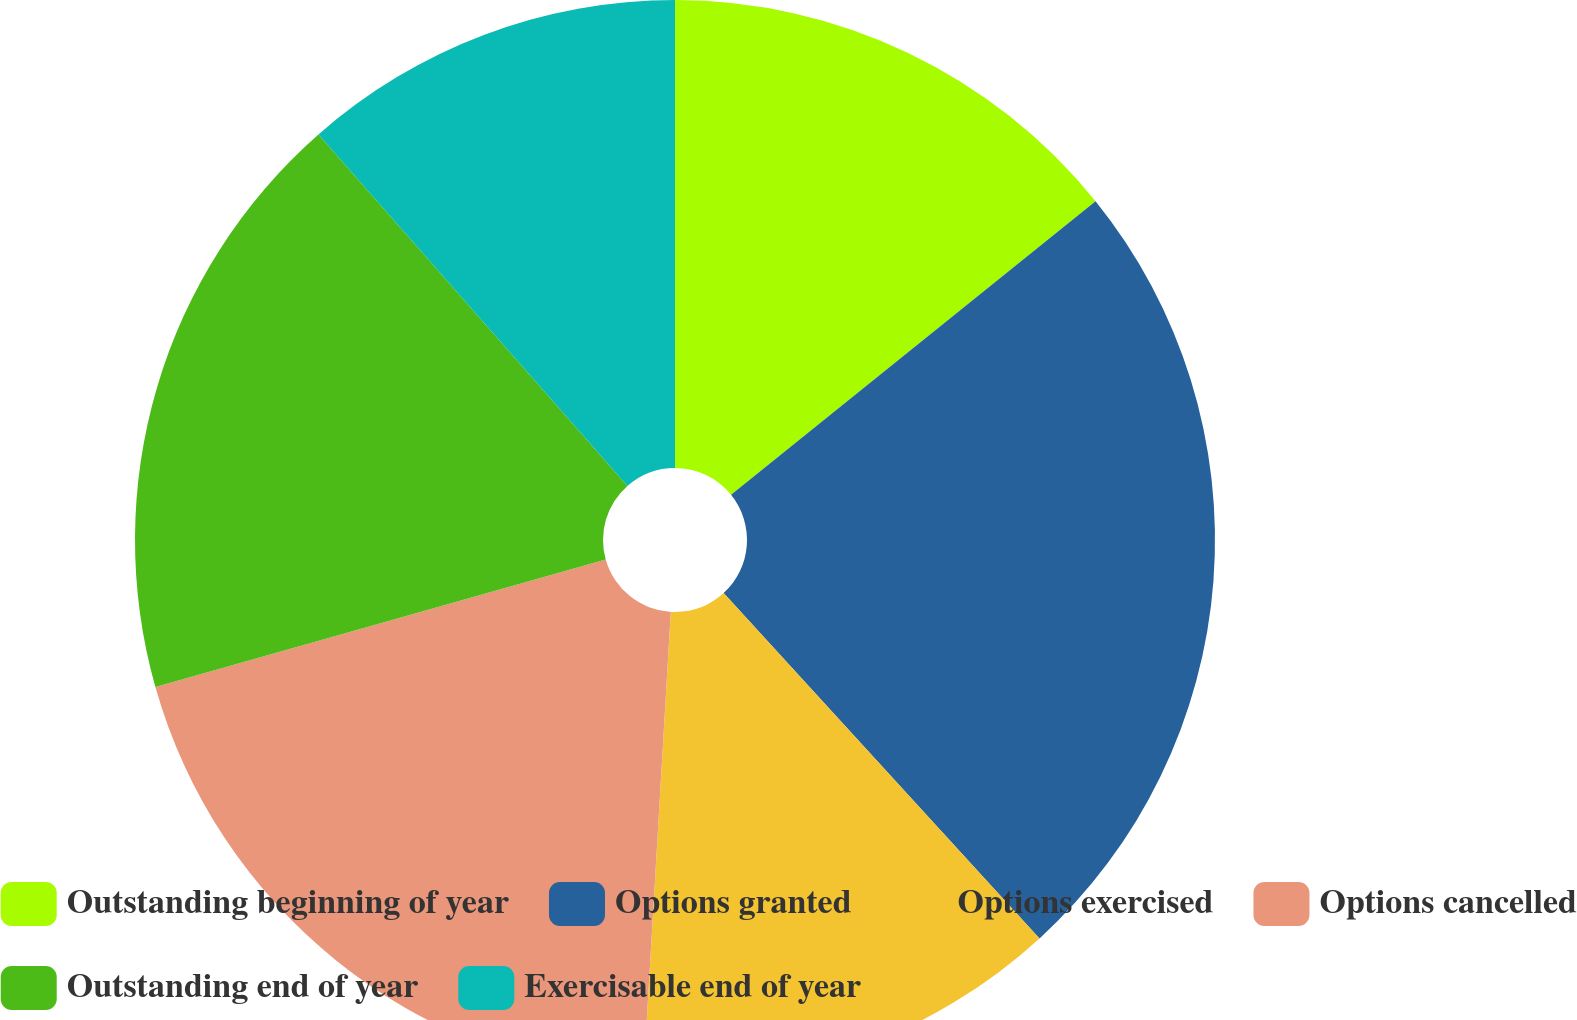<chart> <loc_0><loc_0><loc_500><loc_500><pie_chart><fcel>Outstanding beginning of year<fcel>Options granted<fcel>Options exercised<fcel>Options cancelled<fcel>Outstanding end of year<fcel>Exercisable end of year<nl><fcel>14.21%<fcel>24.0%<fcel>12.73%<fcel>19.68%<fcel>17.91%<fcel>11.48%<nl></chart> 